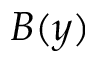Convert formula to latex. <formula><loc_0><loc_0><loc_500><loc_500>B ( y )</formula> 